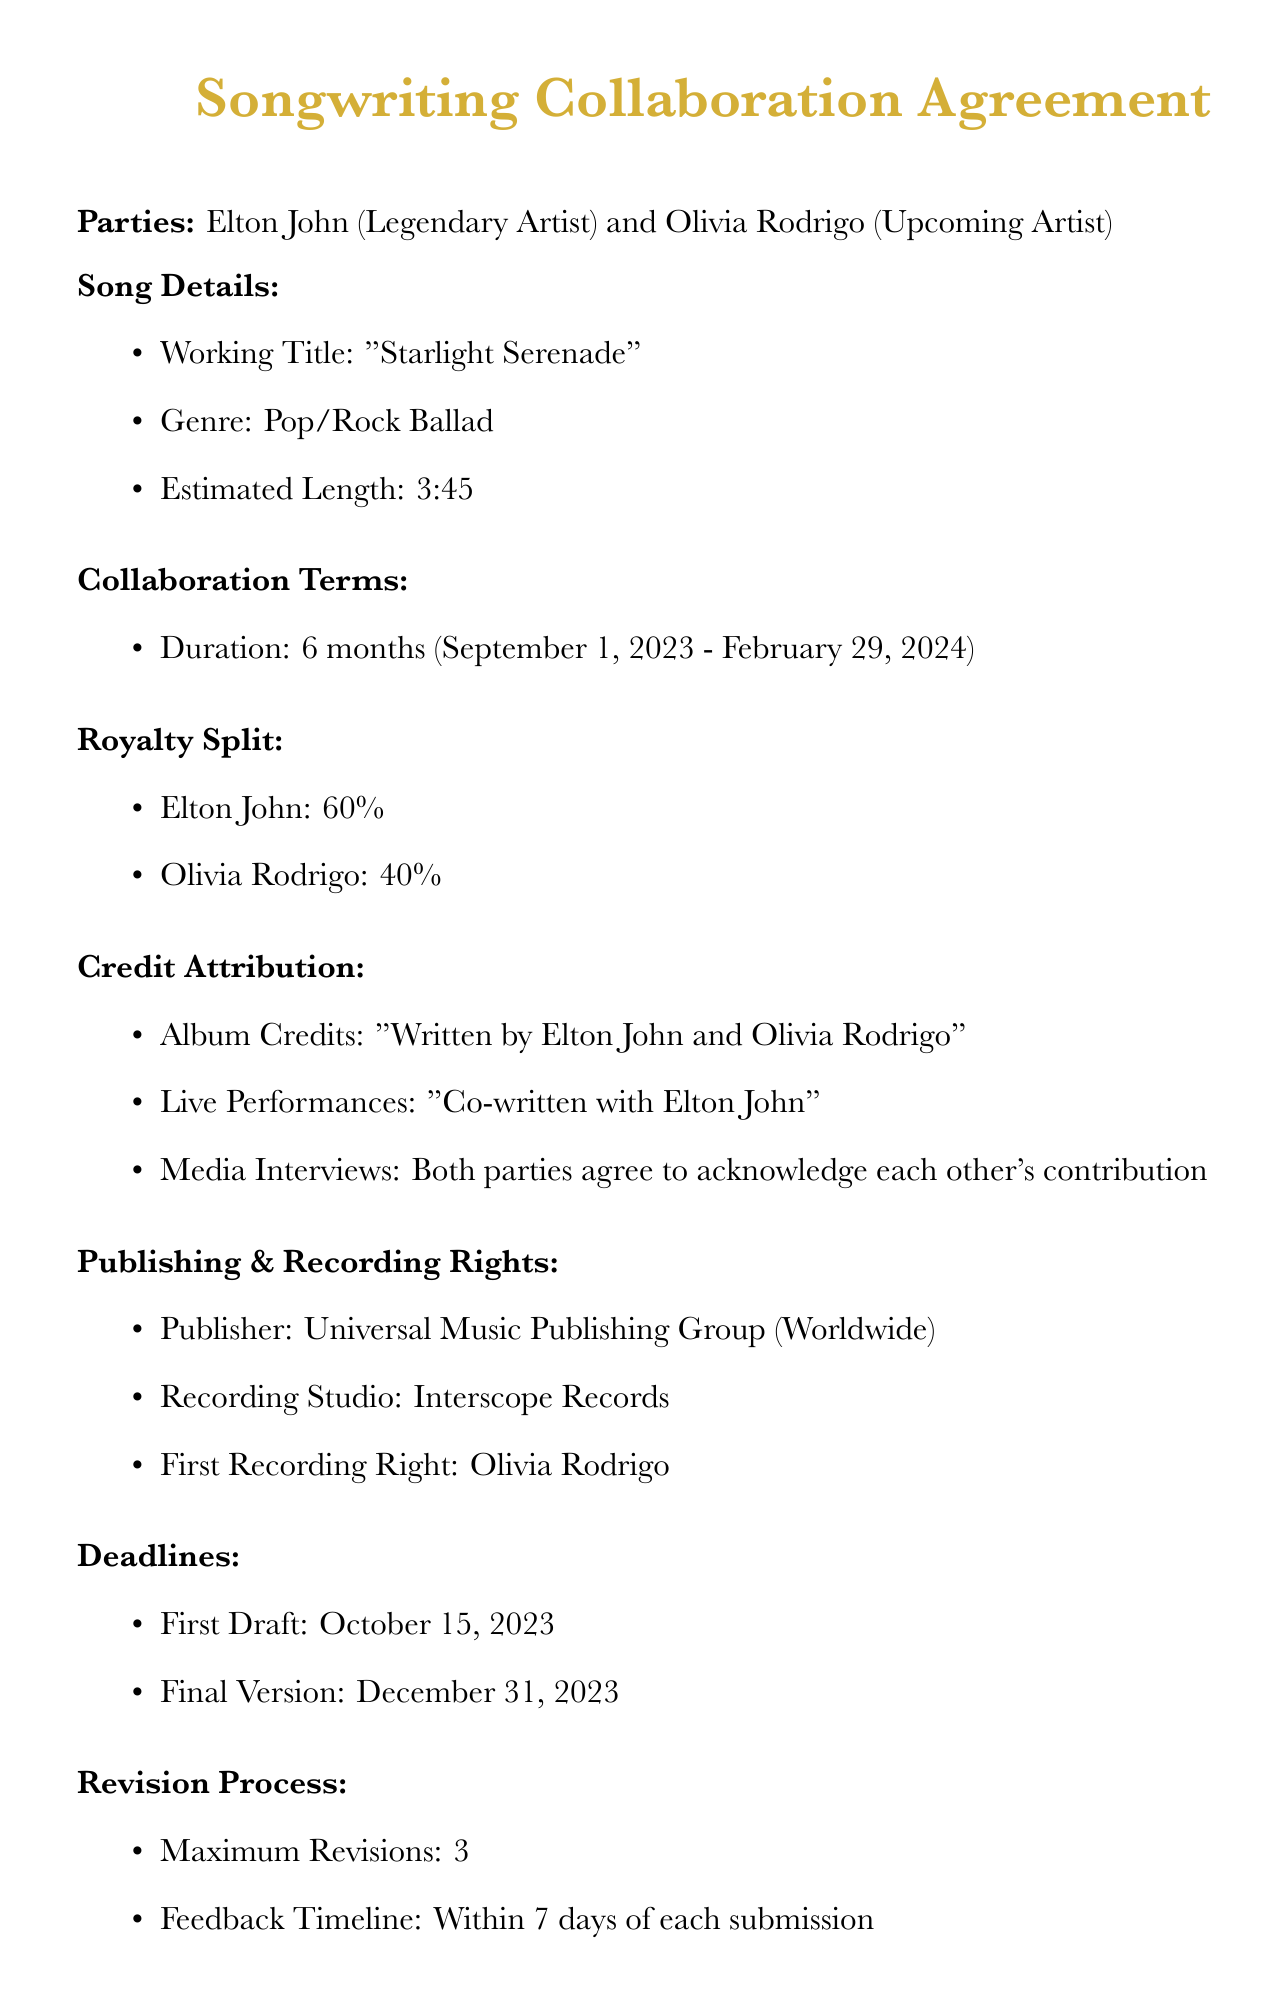What is the working title of the song? The working title is mentioned in the song details section of the document.
Answer: Starlight Serenade Who is the legendary artist involved? The document lists the parties involved, identifying one as the legendary artist.
Answer: Elton John What is the royalty split percentage for Olivia Rodrigo? The royalty split section specifies the percentages allocated to each artist.
Answer: 40% What is the duration of the collaboration? The collaboration terms specify the length of time for the collaboration.
Answer: 6 months What is the deadline for the first draft? The deadlines section indicates when the first draft is due.
Answer: October 15, 2023 What type of rights does Olivia Rodrigo have on the first recording? The section on recording rights specifies the first recording rights held by Olivia.
Answer: First Recording Right How long is the exclusivity clause effective after the release date? The exclusivity clause mentions how long it lasts starting from the release date.
Answer: 12 months Which publisher is listed in the document? The publishing rights section identifies the publisher for the song.
Answer: Universal Music Publishing Group Who will provide mentorship to Olivia Rodrigo? The additional terms state who will be providing mentorship during the collaboration.
Answer: Elton John 